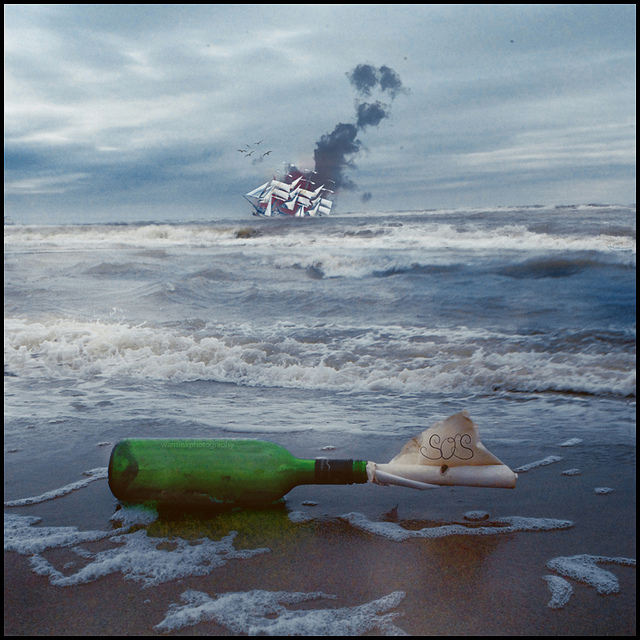Read and extract the text from this image. SOS 